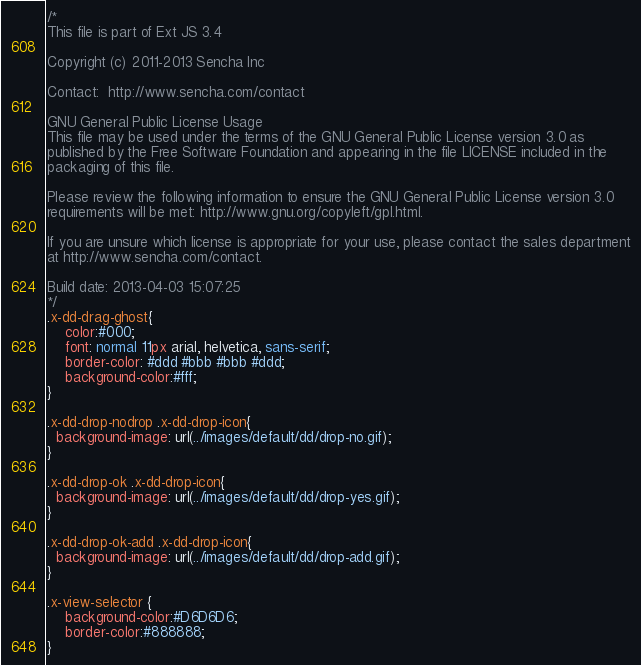Convert code to text. <code><loc_0><loc_0><loc_500><loc_500><_CSS_>/*
This file is part of Ext JS 3.4

Copyright (c) 2011-2013 Sencha Inc

Contact:  http://www.sencha.com/contact

GNU General Public License Usage
This file may be used under the terms of the GNU General Public License version 3.0 as
published by the Free Software Foundation and appearing in the file LICENSE included in the
packaging of this file.

Please review the following information to ensure the GNU General Public License version 3.0
requirements will be met: http://www.gnu.org/copyleft/gpl.html.

If you are unsure which license is appropriate for your use, please contact the sales department
at http://www.sencha.com/contact.

Build date: 2013-04-03 15:07:25
*/
.x-dd-drag-ghost{
	color:#000;
	font: normal 11px arial, helvetica, sans-serif;
    border-color: #ddd #bbb #bbb #ddd;
	background-color:#fff;
}

.x-dd-drop-nodrop .x-dd-drop-icon{
  background-image: url(../images/default/dd/drop-no.gif);
}

.x-dd-drop-ok .x-dd-drop-icon{
  background-image: url(../images/default/dd/drop-yes.gif);
}

.x-dd-drop-ok-add .x-dd-drop-icon{
  background-image: url(../images/default/dd/drop-add.gif);
}

.x-view-selector {
    background-color:#D6D6D6;
    border-color:#888888;
}</code> 